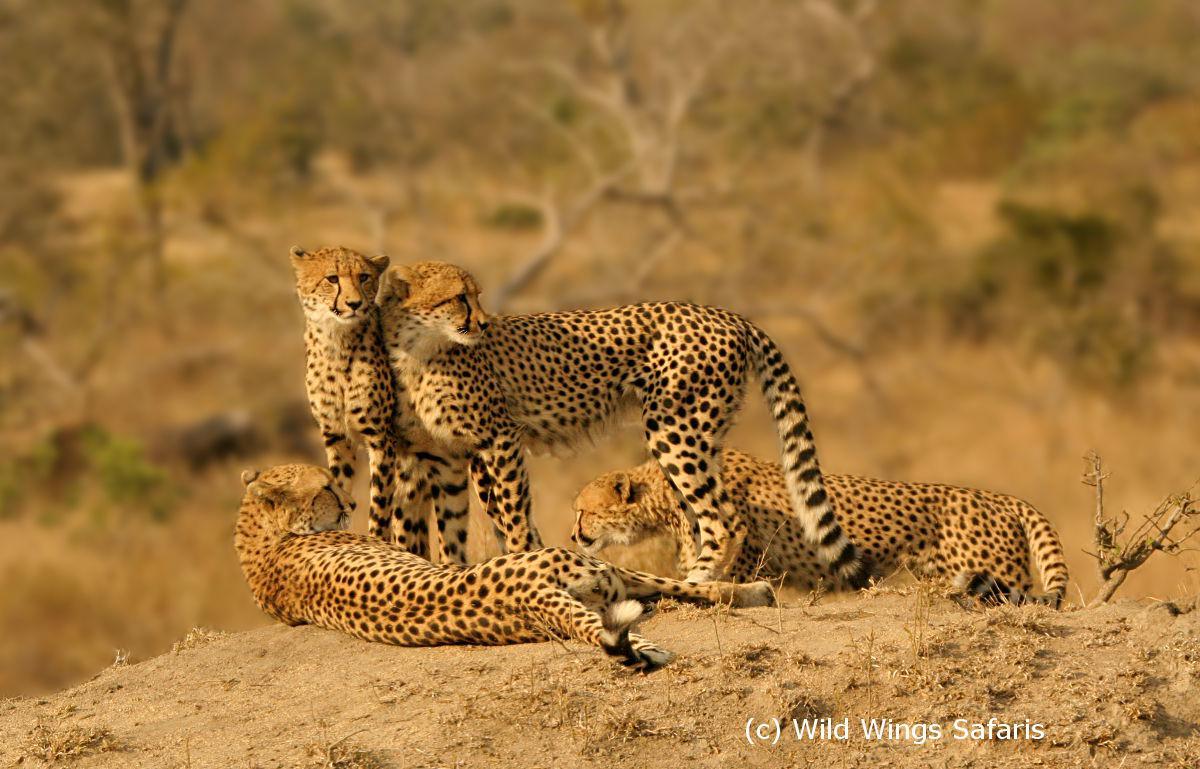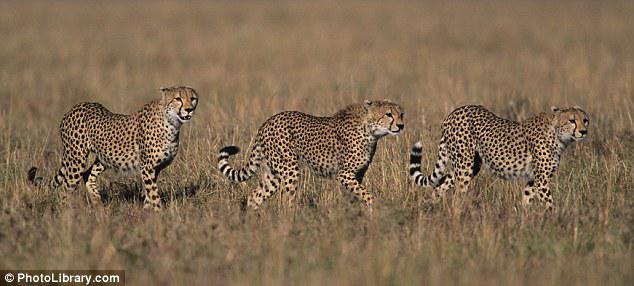The first image is the image on the left, the second image is the image on the right. For the images shown, is this caption "An image shows four cheetahs grouped on a dirt mound, with at least one of them reclining." true? Answer yes or no. Yes. 